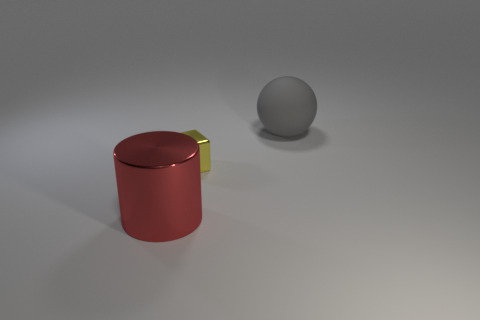Add 2 big gray rubber spheres. How many objects exist? 5 Subtract all cylinders. How many objects are left? 2 Subtract 0 green cylinders. How many objects are left? 3 Subtract all large cyan metallic cylinders. Subtract all tiny yellow objects. How many objects are left? 2 Add 3 tiny yellow objects. How many tiny yellow objects are left? 4 Add 1 metallic things. How many metallic things exist? 3 